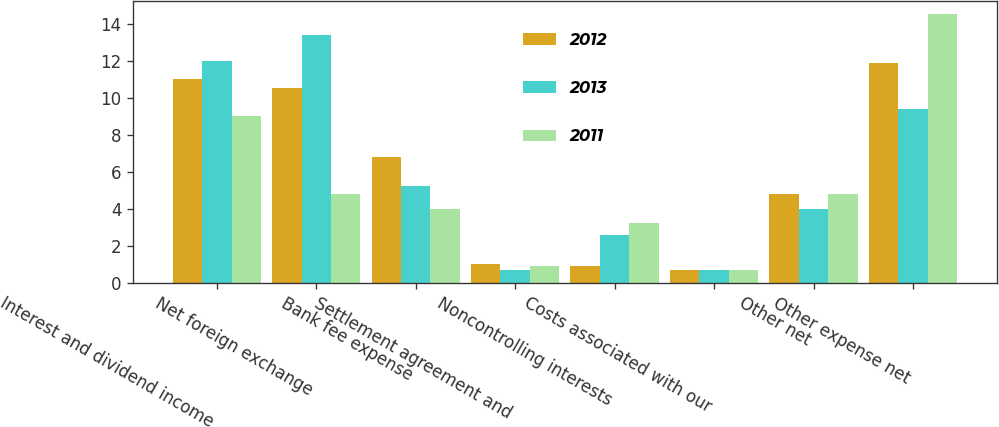Convert chart to OTSL. <chart><loc_0><loc_0><loc_500><loc_500><stacked_bar_chart><ecel><fcel>Interest and dividend income<fcel>Net foreign exchange<fcel>Bank fee expense<fcel>Settlement agreement and<fcel>Noncontrolling interests<fcel>Costs associated with our<fcel>Other net<fcel>Other expense net<nl><fcel>2012<fcel>11<fcel>10.5<fcel>6.8<fcel>1<fcel>0.9<fcel>0.7<fcel>4.8<fcel>11.9<nl><fcel>2013<fcel>12<fcel>13.4<fcel>5.2<fcel>0.7<fcel>2.6<fcel>0.7<fcel>4<fcel>9.4<nl><fcel>2011<fcel>9<fcel>4.8<fcel>4<fcel>0.9<fcel>3.2<fcel>0.7<fcel>4.8<fcel>14.5<nl></chart> 